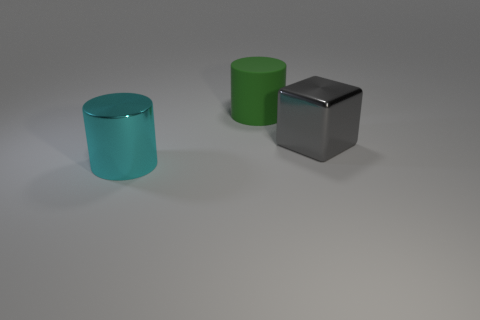Add 2 tiny green cylinders. How many objects exist? 5 Subtract all cubes. How many objects are left? 2 Subtract 0 brown balls. How many objects are left? 3 Subtract all large gray blocks. Subtract all large cylinders. How many objects are left? 0 Add 3 large gray blocks. How many large gray blocks are left? 4 Add 3 metallic cylinders. How many metallic cylinders exist? 4 